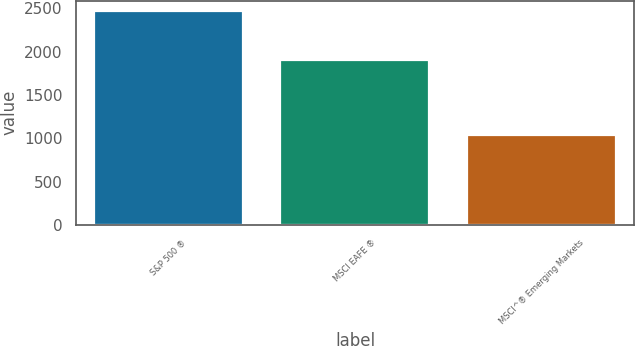Convert chart. <chart><loc_0><loc_0><loc_500><loc_500><bar_chart><fcel>S&P 500 ®<fcel>MSCI EAFE ®<fcel>MSCI^® Emerging Markets<nl><fcel>2465<fcel>1900<fcel>1036<nl></chart> 